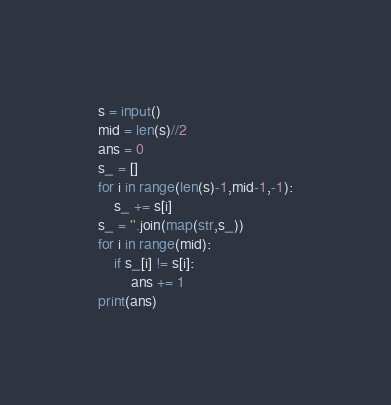Convert code to text. <code><loc_0><loc_0><loc_500><loc_500><_Python_>s = input()
mid = len(s)//2
ans = 0
s_ = []
for i in range(len(s)-1,mid-1,-1):
    s_ += s[i]
s_ = ''.join(map(str,s_))
for i in range(mid):
    if s_[i] != s[i]:
        ans += 1
print(ans)</code> 